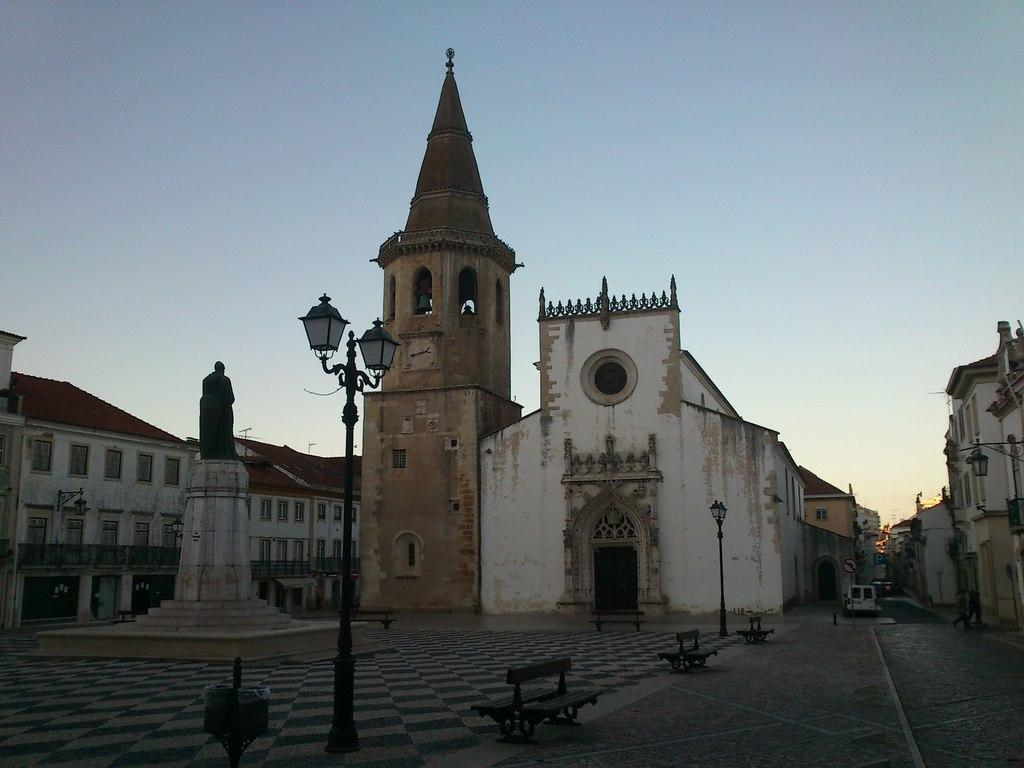What type of seating can be seen in the image? There are benches in the image. What structures are present to provide illumination in the image? There are light poles in the image. What is depicted on the left side of the image? There is a statue of a person on the left side of the image. What can be seen in the distance in the image? There are buildings and vehicles in the background of the image, as well as the sky. What invention is being used by the person in the statue? The statue is of a person, not an actual person, so it cannot use any inventions. How many seats are available on the benches in the image? The number of seats on the benches cannot be determined from the image alone. 